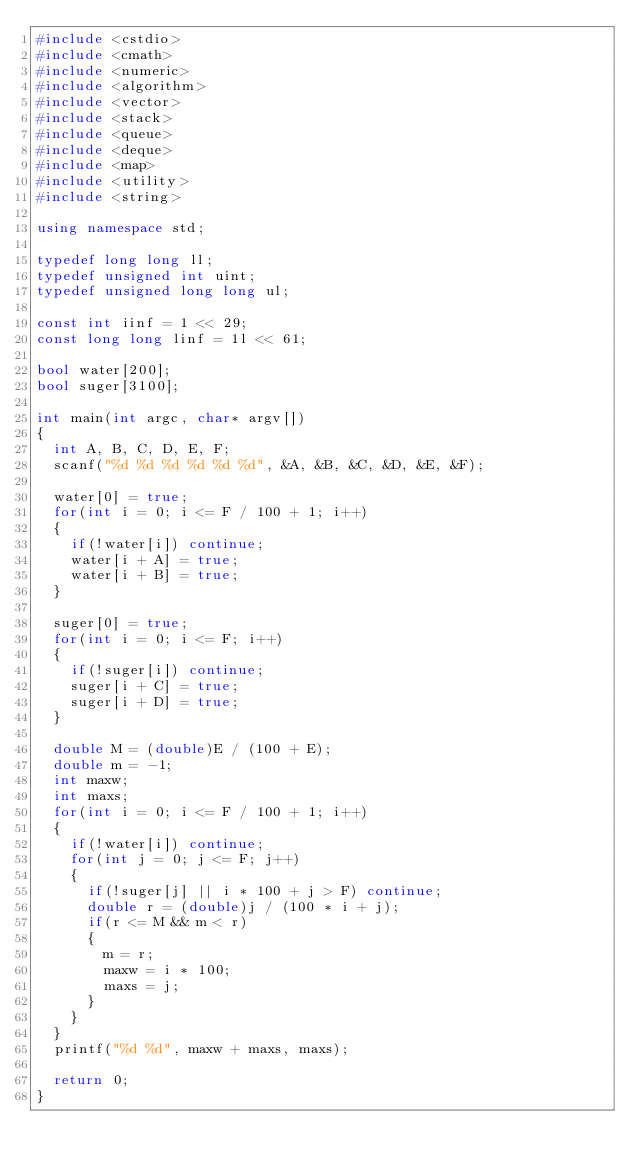<code> <loc_0><loc_0><loc_500><loc_500><_C++_>#include <cstdio>
#include <cmath>
#include <numeric>
#include <algorithm>
#include <vector>
#include <stack>
#include <queue>
#include <deque>
#include <map>
#include <utility>
#include <string>

using namespace std;

typedef long long ll;
typedef unsigned int uint;
typedef unsigned long long ul;

const int iinf = 1 << 29;
const long long linf = 1l << 61;

bool water[200];
bool suger[3100];

int main(int argc, char* argv[])
{
	int A, B, C, D, E, F;
	scanf("%d %d %d %d %d %d", &A, &B, &C, &D, &E, &F);

	water[0] = true;
	for(int i = 0; i <= F / 100 + 1; i++)
	{
		if(!water[i]) continue;
		water[i + A] = true;
		water[i + B] = true;
	}

	suger[0] = true;
	for(int i = 0; i <= F; i++)
	{
		if(!suger[i]) continue;
		suger[i + C] = true;
		suger[i + D] = true;
	}

	double M = (double)E / (100 + E);
	double m = -1;
	int maxw;
	int maxs;
	for(int i = 0; i <= F / 100 + 1; i++)
	{
		if(!water[i]) continue;
		for(int j = 0; j <= F; j++)
		{
			if(!suger[j] || i * 100 + j > F) continue;
			double r = (double)j / (100 * i + j);
			if(r <= M && m < r)
			{
				m = r;
				maxw = i * 100;
				maxs = j;
			}
		}
	}
	printf("%d %d", maxw + maxs, maxs);

	return 0;
}
</code> 